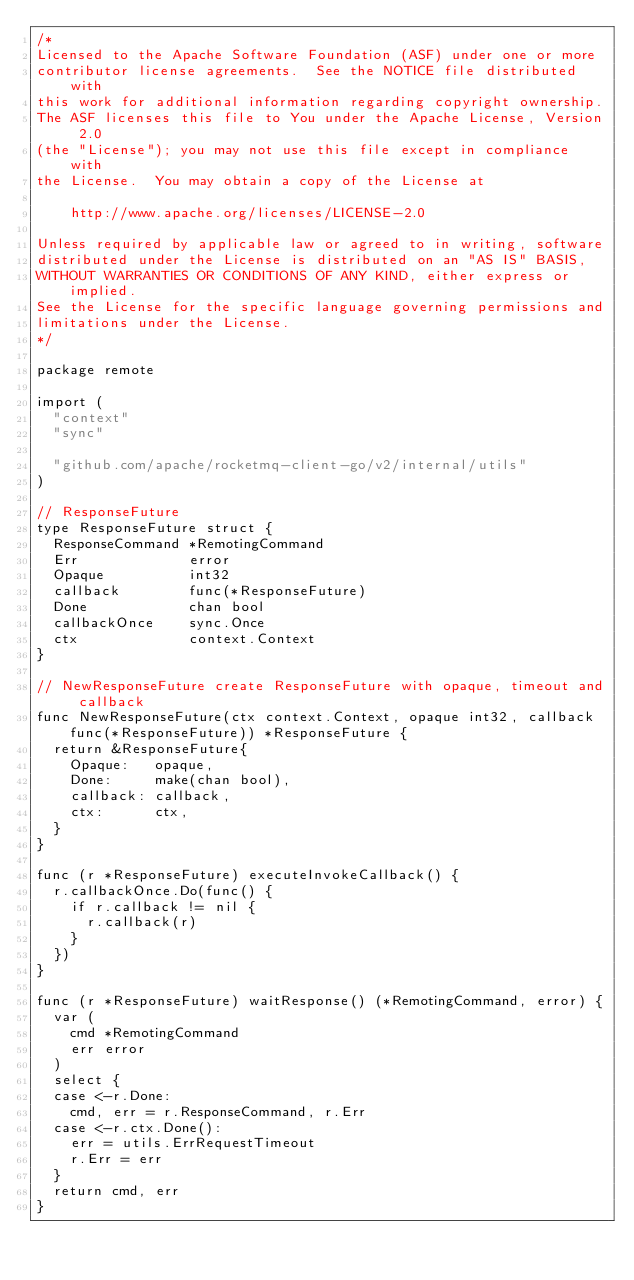Convert code to text. <code><loc_0><loc_0><loc_500><loc_500><_Go_>/*
Licensed to the Apache Software Foundation (ASF) under one or more
contributor license agreements.  See the NOTICE file distributed with
this work for additional information regarding copyright ownership.
The ASF licenses this file to You under the Apache License, Version 2.0
(the "License"); you may not use this file except in compliance with
the License.  You may obtain a copy of the License at

    http://www.apache.org/licenses/LICENSE-2.0

Unless required by applicable law or agreed to in writing, software
distributed under the License is distributed on an "AS IS" BASIS,
WITHOUT WARRANTIES OR CONDITIONS OF ANY KIND, either express or implied.
See the License for the specific language governing permissions and
limitations under the License.
*/

package remote

import (
	"context"
	"sync"

	"github.com/apache/rocketmq-client-go/v2/internal/utils"
)

// ResponseFuture
type ResponseFuture struct {
	ResponseCommand *RemotingCommand
	Err             error
	Opaque          int32
	callback        func(*ResponseFuture)
	Done            chan bool
	callbackOnce    sync.Once
	ctx             context.Context
}

// NewResponseFuture create ResponseFuture with opaque, timeout and callback
func NewResponseFuture(ctx context.Context, opaque int32, callback func(*ResponseFuture)) *ResponseFuture {
	return &ResponseFuture{
		Opaque:   opaque,
		Done:     make(chan bool),
		callback: callback,
		ctx:      ctx,
	}
}

func (r *ResponseFuture) executeInvokeCallback() {
	r.callbackOnce.Do(func() {
		if r.callback != nil {
			r.callback(r)
		}
	})
}

func (r *ResponseFuture) waitResponse() (*RemotingCommand, error) {
	var (
		cmd *RemotingCommand
		err error
	)
	select {
	case <-r.Done:
		cmd, err = r.ResponseCommand, r.Err
	case <-r.ctx.Done():
		err = utils.ErrRequestTimeout
		r.Err = err
	}
	return cmd, err
}
</code> 